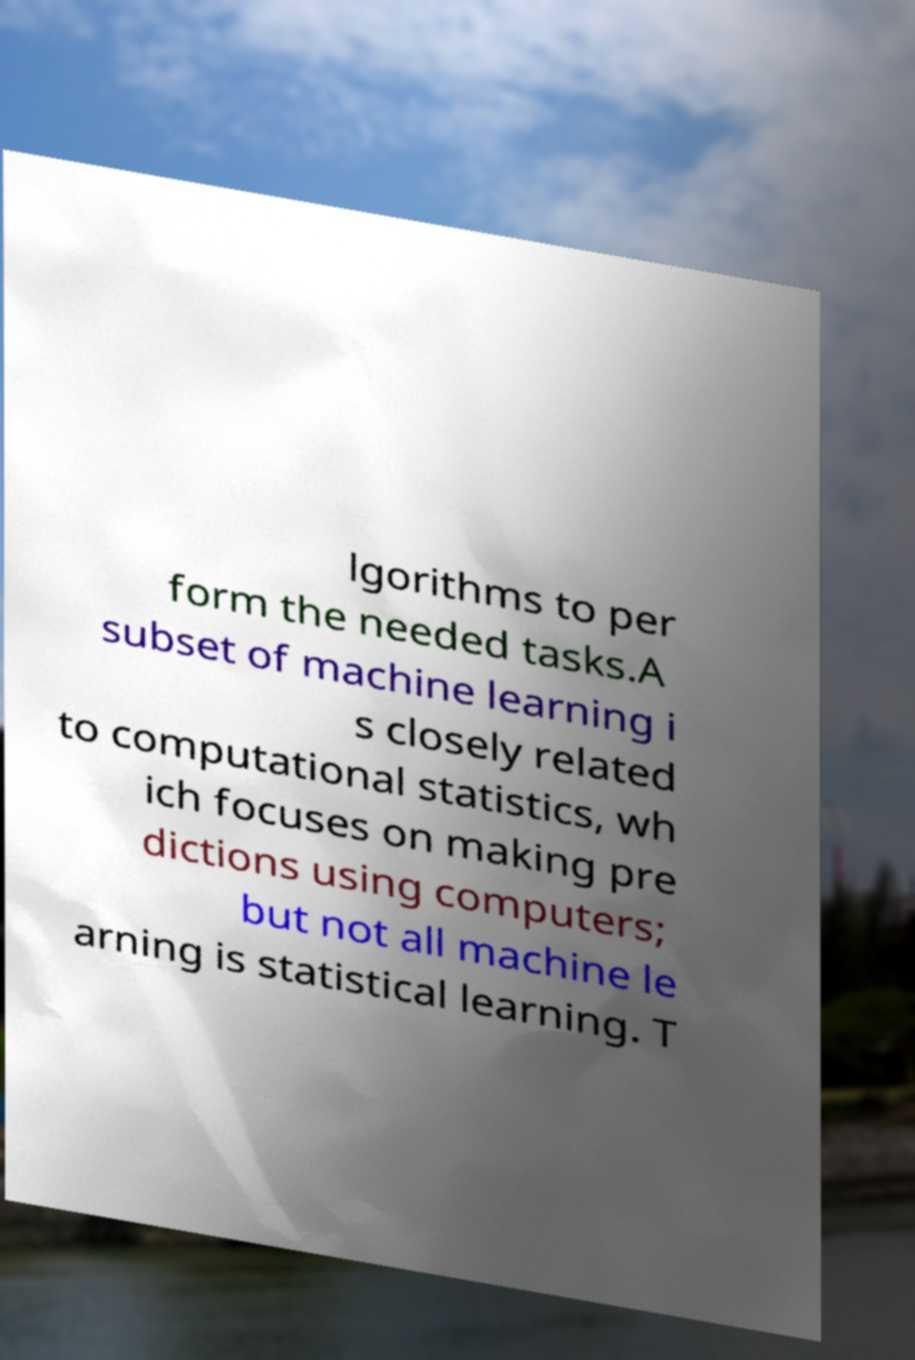For documentation purposes, I need the text within this image transcribed. Could you provide that? lgorithms to per form the needed tasks.A subset of machine learning i s closely related to computational statistics, wh ich focuses on making pre dictions using computers; but not all machine le arning is statistical learning. T 